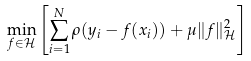Convert formula to latex. <formula><loc_0><loc_0><loc_500><loc_500>\min _ { f \in \mathcal { H } } \left [ \sum _ { i = 1 } ^ { N } \rho ( y _ { i } - f ( x _ { i } ) ) + \mu \| f \| _ { \mathcal { H } } ^ { 2 } \right ]</formula> 